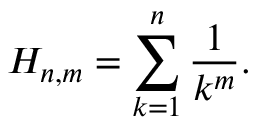Convert formula to latex. <formula><loc_0><loc_0><loc_500><loc_500>H _ { n , m } = \sum _ { k = 1 } ^ { n } { \frac { 1 } { k ^ { m } } } .</formula> 